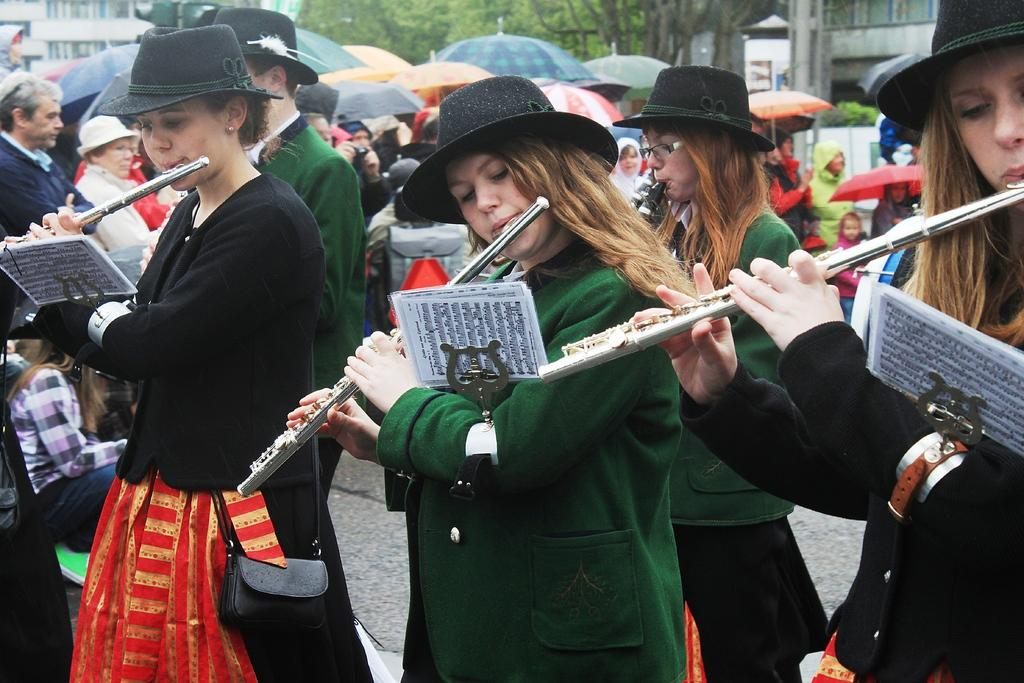How many girls are in the image? There are three girls in the image. What are the girls doing in the image? The girls are playing flutes. Can you describe the dresses worn by the girls? One girl is wearing a green dress, and another girl is wearing a black dress. What other objects can be seen in the image? There are umbrellas visible in the image. What type of prison can be seen in the background of the image? There is no prison present in the image; it features three girls playing flutes and umbrellas. Can you describe the stranger standing next to the girls in the image? There is no stranger present in the image; it only shows three girls playing flutes and umbrellas. 